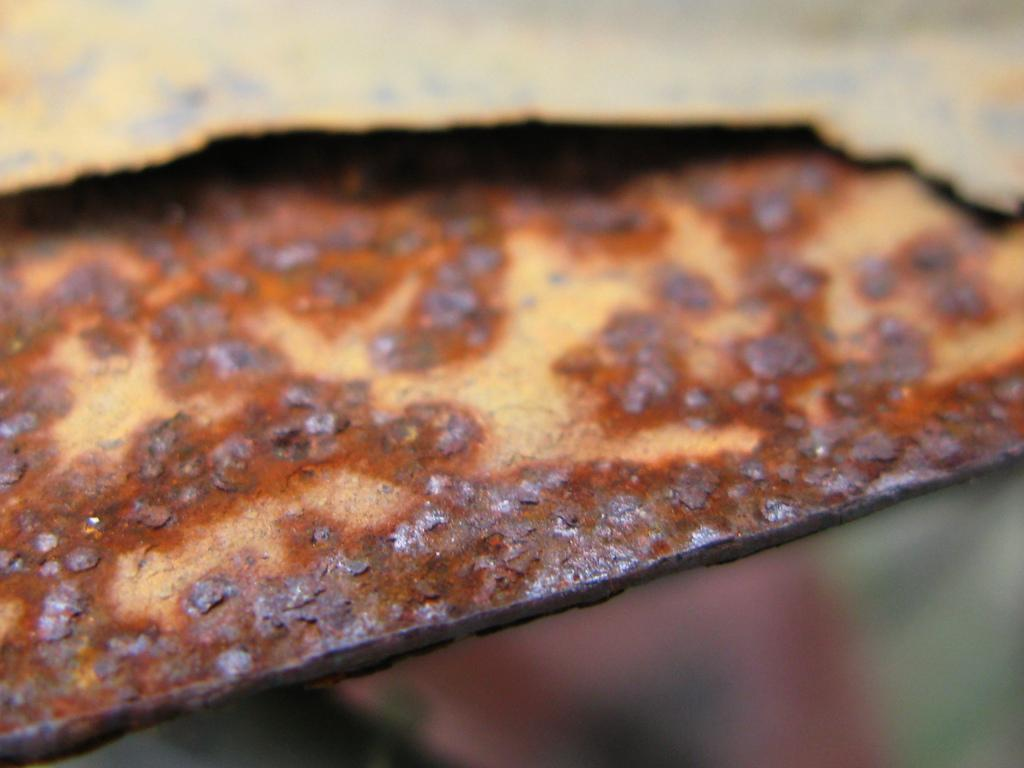What material is the object in the image made of? The object in the image is made of iron. Can you describe the condition of the iron object? The piece of iron has rust on it. What type of straw is being used to measure the rate of the iron object in the image? There is no straw or measurement of any kind present in the image. 